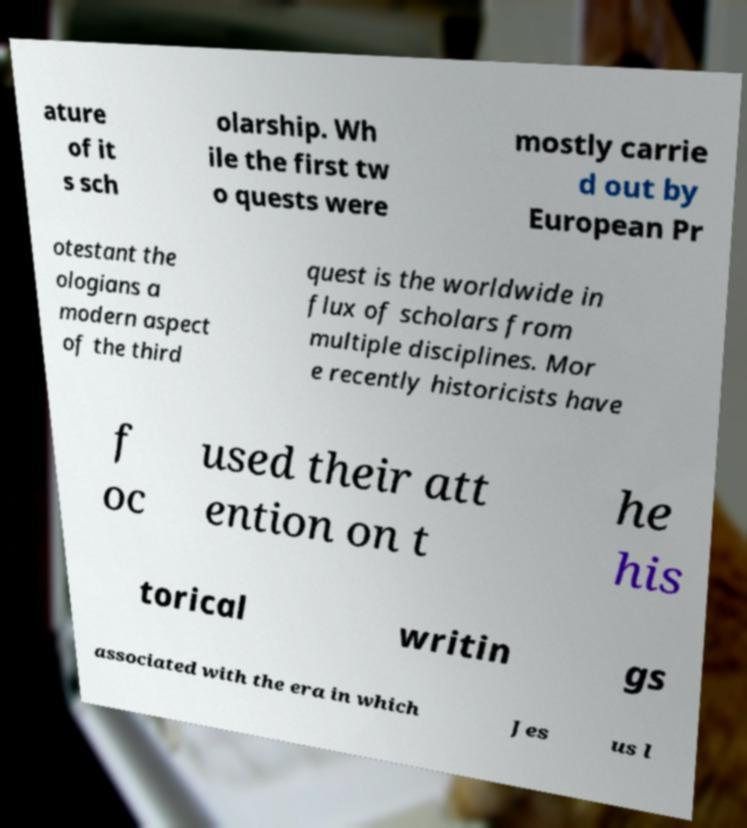There's text embedded in this image that I need extracted. Can you transcribe it verbatim? ature of it s sch olarship. Wh ile the first tw o quests were mostly carrie d out by European Pr otestant the ologians a modern aspect of the third quest is the worldwide in flux of scholars from multiple disciplines. Mor e recently historicists have f oc used their att ention on t he his torical writin gs associated with the era in which Jes us l 